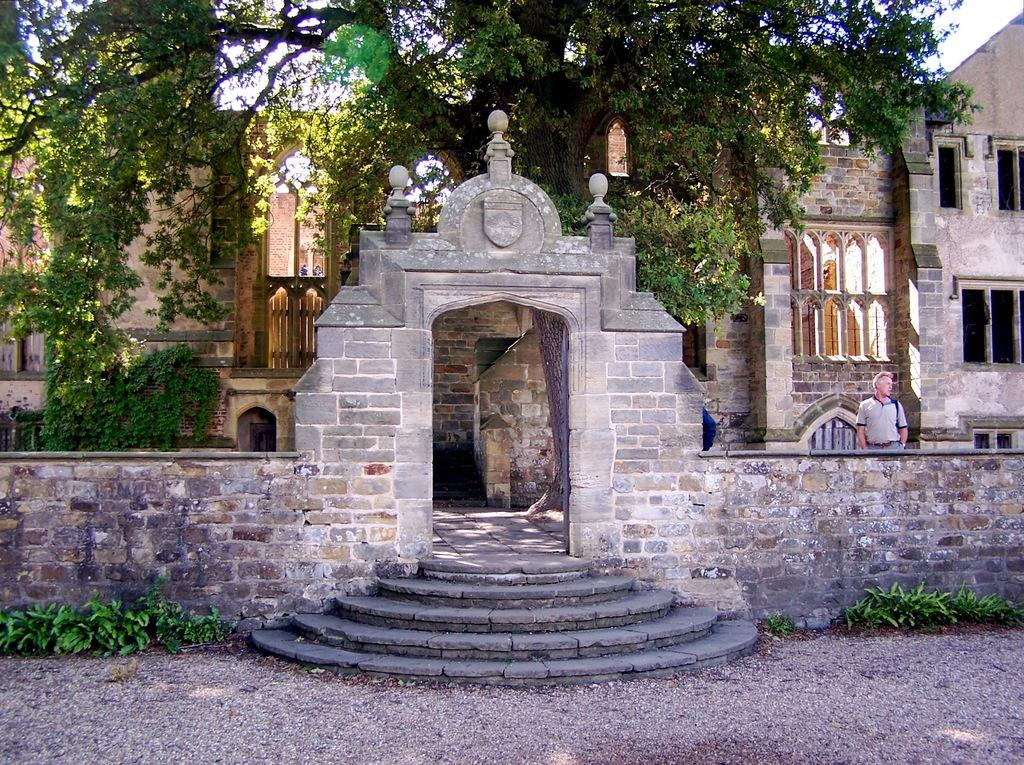What type of structure is visible in the image? There is an old construction in the image. Can you describe the man's position in the image? The man is on the right side of the image. What type of vegetation can be seen in the image? There are trees at the back side of the image. How does the goose move in the image? There is no goose present in the image. What type of growth can be seen on the old construction in the image? The provided facts do not mention any growth on the old construction. 